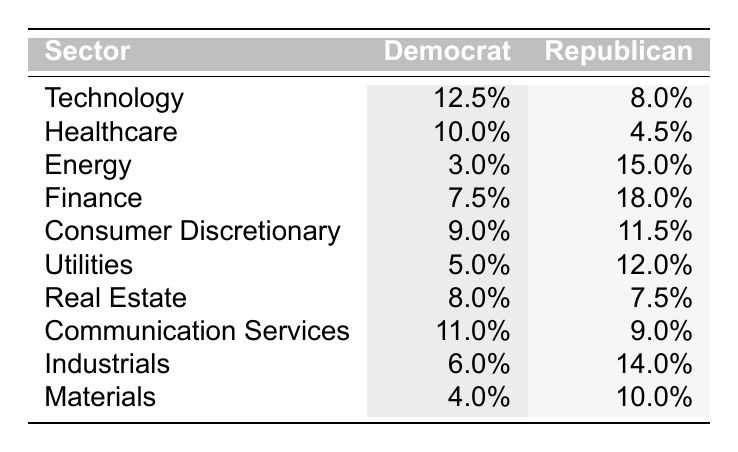What is the performance percentage of the Technology sector under Democrat leadership? The table lists the Technology sector's performance under Democrat leadership as 12.5%.
Answer: 12.5% Which sector shows the highest performance under Republican leadership? By comparing the performance percentages for each sector under Republican leadership, the Finance sector has the highest performance at 18.0%.
Answer: 18.0% What is the difference in performance between the Healthcare sector under Democrat and Republican leadership? The Healthcare sector shows a performance of 10.0% under Democrats and 4.5% under Republicans. The difference is calculated as 10.0% - 4.5% = 5.5%.
Answer: 5.5% Is the performance of the Energy sector under Democrat leadership higher than that under Republican leadership? The Energy sector's performance is 3.0% under Democrat leadership and 15.0% under Republican leadership. Since 3.0% is less than 15.0%, the statement is false.
Answer: No What is the average performance percentage of all sectors under Democrat leadership? To find the average, sum all Democrat performances: 12.5 + 10.0 + 3.0 + 7.5 + 9.0 + 5.0 + 8.0 + 11.0 + 6.0 + 4.0 = 66.0%. There are 10 sectors, so the average is 66.0% / 10 = 6.6%.
Answer: 6.6% Which sector has a better performance under Democrat leadership than under Republican leadership? By reviewing the performances, we see that the Technology, Healthcare, Consumer Discretionary, Utilities, Real Estate, and Communication Services sectors all perform better under Democrat leadership compared to Republican leadership.
Answer: Technology, Healthcare, Consumer Discretionary, Utilities, Real Estate, Communication Services What is the combined performance of the Consumer Discretionary and Utilities sectors under Republican leadership? The Consumer Discretionary sector performs at 11.5% and the Utilities sector at 12.0% under Republican leadership. Adding these values gives 11.5% + 12.0% = 23.5%.
Answer: 23.5% Which political party had better overall performance in the Finance sector? The Finance sector shows a performance of 7.5% under Democrat leadership and 18.0% under Republican leadership. Since 18.0% is greater, the Republican party had better performance in this sector.
Answer: Republican Do the Democrats have a higher performance in any sector compared to the Republicans? Examining the table, the Democrats have higher performance in the Technology (12.5% vs. 8.0%), Healthcare (10.0% vs. 4.5%), Consumer Discretionary (9.0% vs. 11.5%), Utilities (5.0% vs. 12.0%), Real Estate (8.0% vs. 7.5%), and Communication Services (11.0% vs. 9.0%) sectors, demonstrating they have better performance in several sectors.
Answer: Yes 